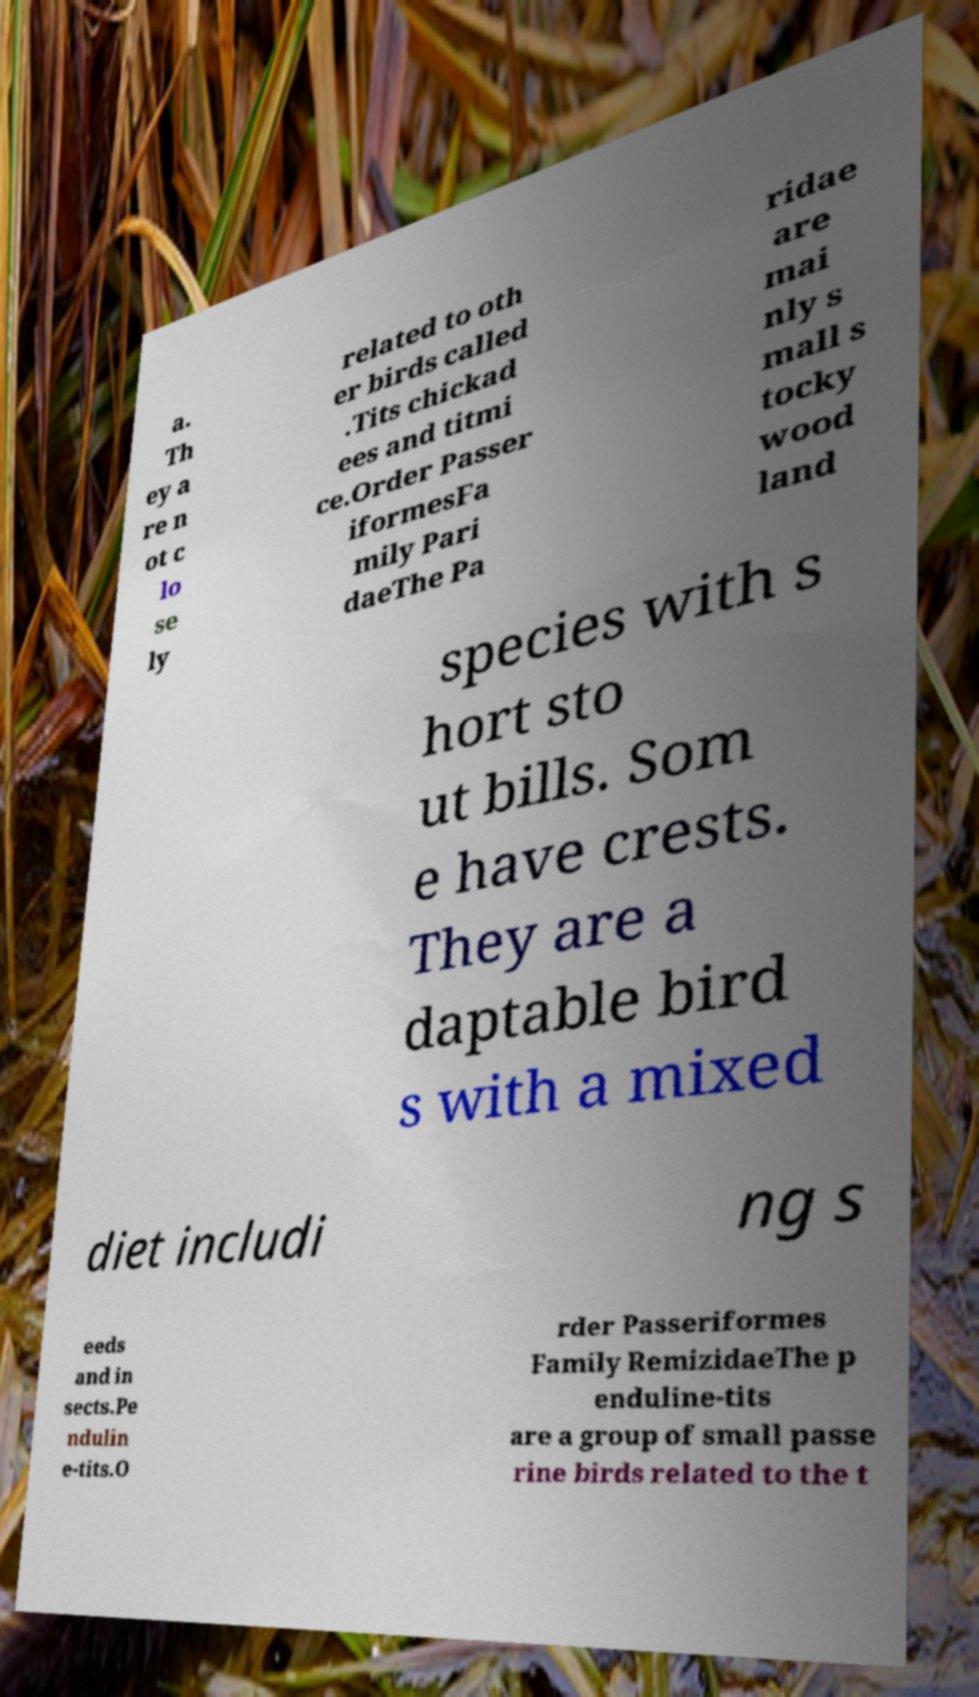Can you accurately transcribe the text from the provided image for me? a. Th ey a re n ot c lo se ly related to oth er birds called .Tits chickad ees and titmi ce.Order Passer iformesFa mily Pari daeThe Pa ridae are mai nly s mall s tocky wood land species with s hort sto ut bills. Som e have crests. They are a daptable bird s with a mixed diet includi ng s eeds and in sects.Pe ndulin e-tits.O rder Passeriformes Family RemizidaeThe p enduline-tits are a group of small passe rine birds related to the t 